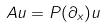Convert formula to latex. <formula><loc_0><loc_0><loc_500><loc_500>A u = P ( \partial _ { x } ) u</formula> 